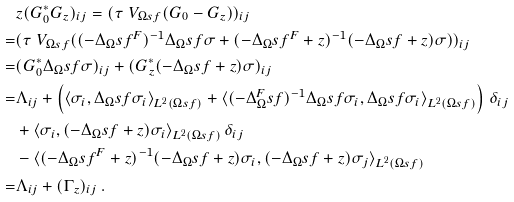Convert formula to latex. <formula><loc_0><loc_0><loc_500><loc_500>& z ( G ^ { * } _ { 0 } G _ { z } ) _ { i j } = ( \tau ^ { \ } V _ { \Omega s f } ( G _ { 0 } - G _ { z } ) ) _ { i j } \\ = & ( \tau ^ { \ } V _ { \Omega s f } ( ( - \Delta _ { \Omega } s f ^ { F } ) ^ { - 1 } \Delta _ { \Omega } s f \sigma + ( - \Delta _ { \Omega } s f ^ { F } + z ) ^ { - 1 } ( - \Delta _ { \Omega } s f + z ) \sigma ) ) _ { i j } \\ = & ( G _ { 0 } ^ { * } \Delta _ { \Omega } s f \sigma ) _ { i j } + ( G _ { z } ^ { * } ( - \Delta _ { \Omega } s f + z ) \sigma ) _ { i j } \\ = & \Lambda _ { i j } + \left ( \langle \sigma _ { i } , \Delta _ { \Omega } s f \sigma _ { i } \rangle _ { L ^ { 2 } ( \Omega s f ) } + \langle ( - \Delta ^ { F } _ { \Omega } s f ) ^ { - 1 } \Delta _ { \Omega } s f \sigma _ { i } , \Delta _ { \Omega } s f \sigma _ { i } \rangle _ { L ^ { 2 } ( \Omega s f ) } \right ) \, \delta _ { i j } \\ & + \langle \sigma _ { i } , ( - \Delta _ { \Omega } s f + z ) \sigma _ { i } \rangle _ { L ^ { 2 } ( \Omega s f ) } \, \delta _ { i j } \\ & - \langle ( - \Delta _ { \Omega } s f ^ { F } + z ) ^ { - 1 } ( - \Delta _ { \Omega } s f + z ) \sigma _ { i } , ( - \Delta _ { \Omega } s f + z ) \sigma _ { j } \rangle _ { L ^ { 2 } ( \Omega s f ) } \\ = & \Lambda _ { i j } + ( \Gamma _ { z } ) _ { i j } \, .</formula> 